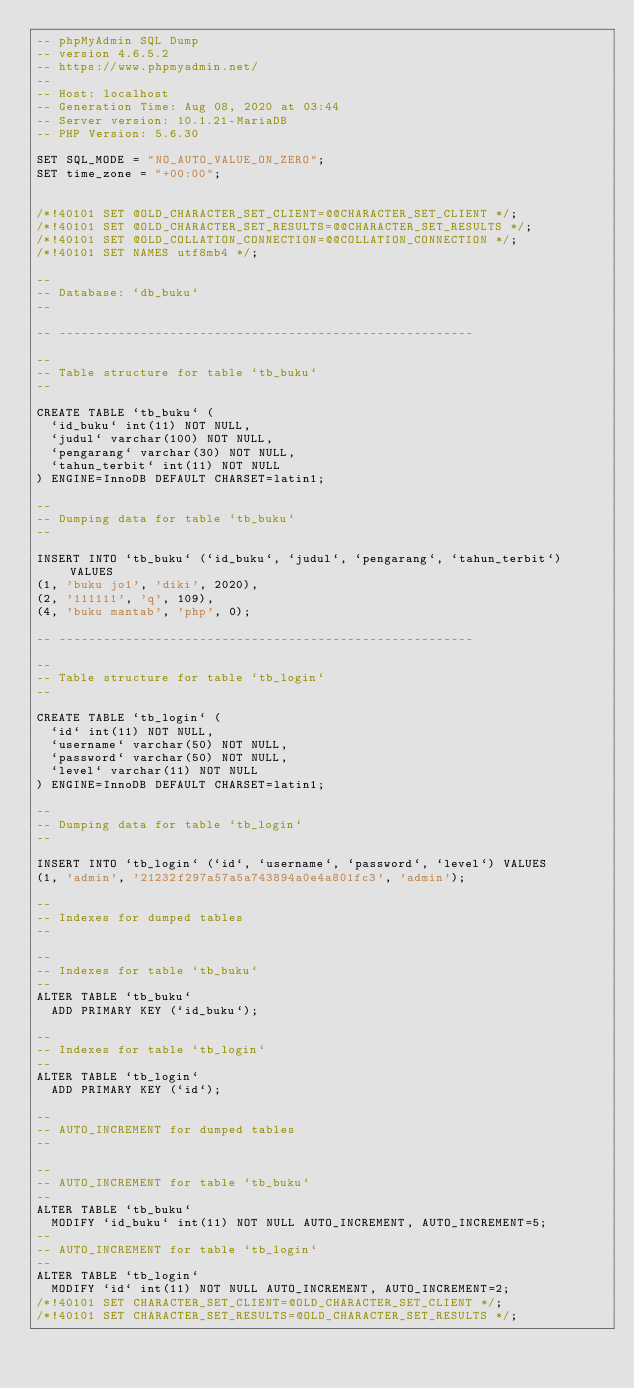<code> <loc_0><loc_0><loc_500><loc_500><_SQL_>-- phpMyAdmin SQL Dump
-- version 4.6.5.2
-- https://www.phpmyadmin.net/
--
-- Host: localhost
-- Generation Time: Aug 08, 2020 at 03:44 
-- Server version: 10.1.21-MariaDB
-- PHP Version: 5.6.30

SET SQL_MODE = "NO_AUTO_VALUE_ON_ZERO";
SET time_zone = "+00:00";


/*!40101 SET @OLD_CHARACTER_SET_CLIENT=@@CHARACTER_SET_CLIENT */;
/*!40101 SET @OLD_CHARACTER_SET_RESULTS=@@CHARACTER_SET_RESULTS */;
/*!40101 SET @OLD_COLLATION_CONNECTION=@@COLLATION_CONNECTION */;
/*!40101 SET NAMES utf8mb4 */;

--
-- Database: `db_buku`
--

-- --------------------------------------------------------

--
-- Table structure for table `tb_buku`
--

CREATE TABLE `tb_buku` (
  `id_buku` int(11) NOT NULL,
  `judul` varchar(100) NOT NULL,
  `pengarang` varchar(30) NOT NULL,
  `tahun_terbit` int(11) NOT NULL
) ENGINE=InnoDB DEFAULT CHARSET=latin1;

--
-- Dumping data for table `tb_buku`
--

INSERT INTO `tb_buku` (`id_buku`, `judul`, `pengarang`, `tahun_terbit`) VALUES
(1, 'buku jo1', 'diki', 2020),
(2, '111111', 'q', 109),
(4, 'buku mantab', 'php', 0);

-- --------------------------------------------------------

--
-- Table structure for table `tb_login`
--

CREATE TABLE `tb_login` (
  `id` int(11) NOT NULL,
  `username` varchar(50) NOT NULL,
  `password` varchar(50) NOT NULL,
  `level` varchar(11) NOT NULL
) ENGINE=InnoDB DEFAULT CHARSET=latin1;

--
-- Dumping data for table `tb_login`
--

INSERT INTO `tb_login` (`id`, `username`, `password`, `level`) VALUES
(1, 'admin', '21232f297a57a5a743894a0e4a801fc3', 'admin');

--
-- Indexes for dumped tables
--

--
-- Indexes for table `tb_buku`
--
ALTER TABLE `tb_buku`
  ADD PRIMARY KEY (`id_buku`);

--
-- Indexes for table `tb_login`
--
ALTER TABLE `tb_login`
  ADD PRIMARY KEY (`id`);

--
-- AUTO_INCREMENT for dumped tables
--

--
-- AUTO_INCREMENT for table `tb_buku`
--
ALTER TABLE `tb_buku`
  MODIFY `id_buku` int(11) NOT NULL AUTO_INCREMENT, AUTO_INCREMENT=5;
--
-- AUTO_INCREMENT for table `tb_login`
--
ALTER TABLE `tb_login`
  MODIFY `id` int(11) NOT NULL AUTO_INCREMENT, AUTO_INCREMENT=2;
/*!40101 SET CHARACTER_SET_CLIENT=@OLD_CHARACTER_SET_CLIENT */;
/*!40101 SET CHARACTER_SET_RESULTS=@OLD_CHARACTER_SET_RESULTS */;</code> 